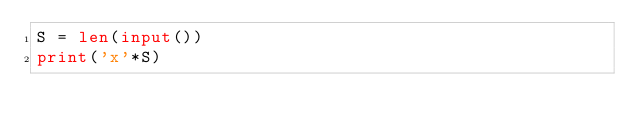Convert code to text. <code><loc_0><loc_0><loc_500><loc_500><_Python_>S = len(input())
print('x'*S)</code> 